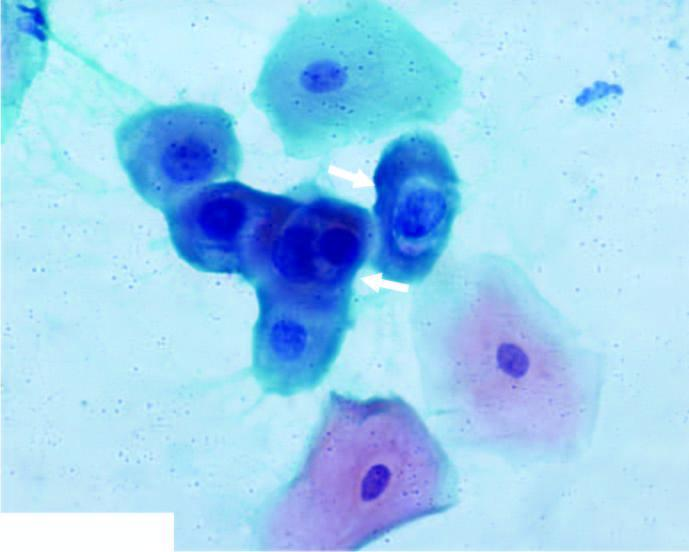does the smear show koilocytes having abundant vacuolated cytoplasm and nuclear enlargement?
Answer the question using a single word or phrase. Yes 